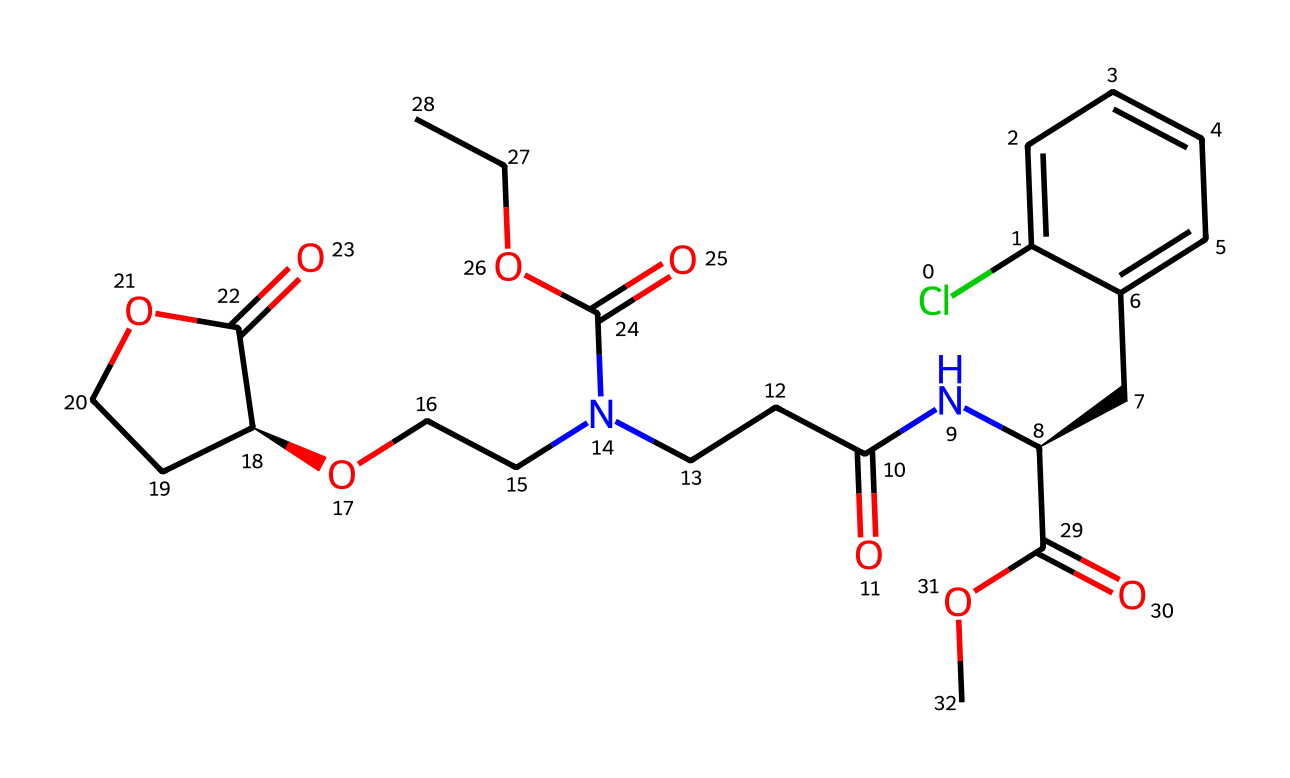What is the total number of chiral centers in this compound? To determine this, we need to identify the carbon atoms that are bonded to four different substituents. In the provided SMILES, there is one carbon indicated with '[C@H]', which denotes a chiral center. Therefore, there is a total of one chiral center in the compound.
Answer: 1 Which functional group is responsible for the activity of this calcium channel blocker? The presence of the nitrogen atom within an amide group (from the 'NC(=O)' portion) suggests that this functional group contributes to the biological activity, especially as it’s connected to the calcium channel blocking mechanism.
Answer: amide How many oxygen atoms are present in the structure? By analyzing the SMILES representation, we can count the 'O' characters which indicate the presence of oxygen atoms. Summing them up, the compound contains six oxygen atoms.
Answer: 6 What is the molecular weight of this compound? The molecular weight can be calculated from the individual atomic weights of the components present in the structure, including carbons, hydrogens, oxygens, and nitrogens. This results in a molecular weight of approximately 567.7 g/mol.
Answer: 567.7 g/mol Is this compound a racemic mixture? A racemic mixture typically contains equal amounts of both enantiomers, but since the SMILES structure indicates a specific chiral center with '@' notation that specifies chirality, this suggests it is not a racemic mixture.
Answer: No What type of stereochemical configuration does the chiral center possess? The '[C@H]' notation indicates that the stereochemical configuration is 'R' (rectus) or 'S' (sinister). However, without additional stereochemical context, it is specified here as 'C@H', indicating a specific stereocenter.
Answer: C@H 